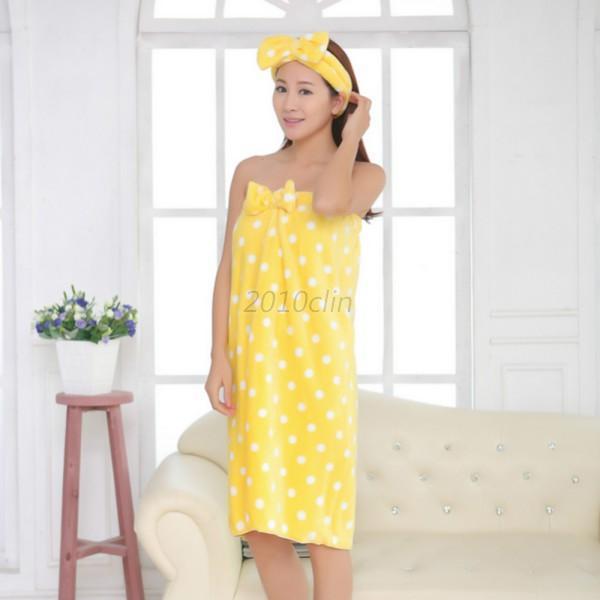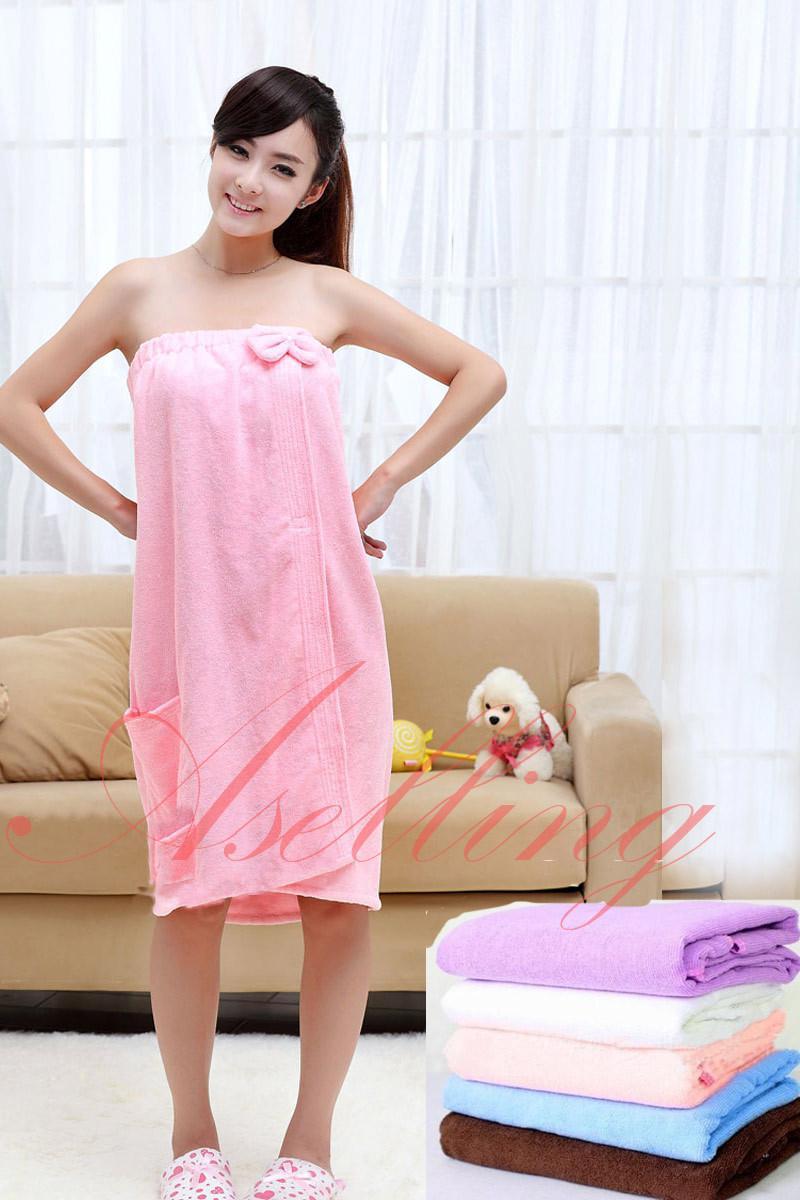The first image is the image on the left, the second image is the image on the right. Evaluate the accuracy of this statement regarding the images: "At least one of the women has her hand to her face.". Is it true? Answer yes or no. Yes. The first image is the image on the left, the second image is the image on the right. Evaluate the accuracy of this statement regarding the images: "One woman's towel is pink with white polka dots.". Is it true? Answer yes or no. No. 